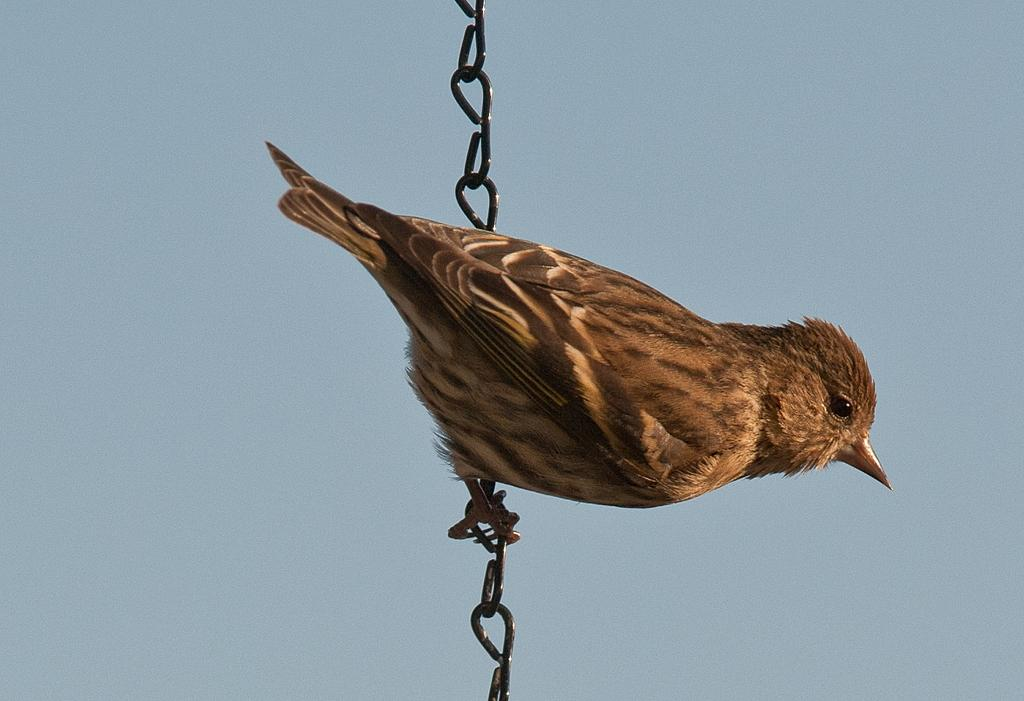What type of animal is in the image? There is a bird in the image. How is the bird positioned in the image? The bird is on a chain. What can be seen in the background of the image? The sky is visible in the background of the image. How much does the cabbage weigh on the scale in the image? There is no cabbage or scale present in the image; it only features a bird on a chain with the sky visible in the background. 